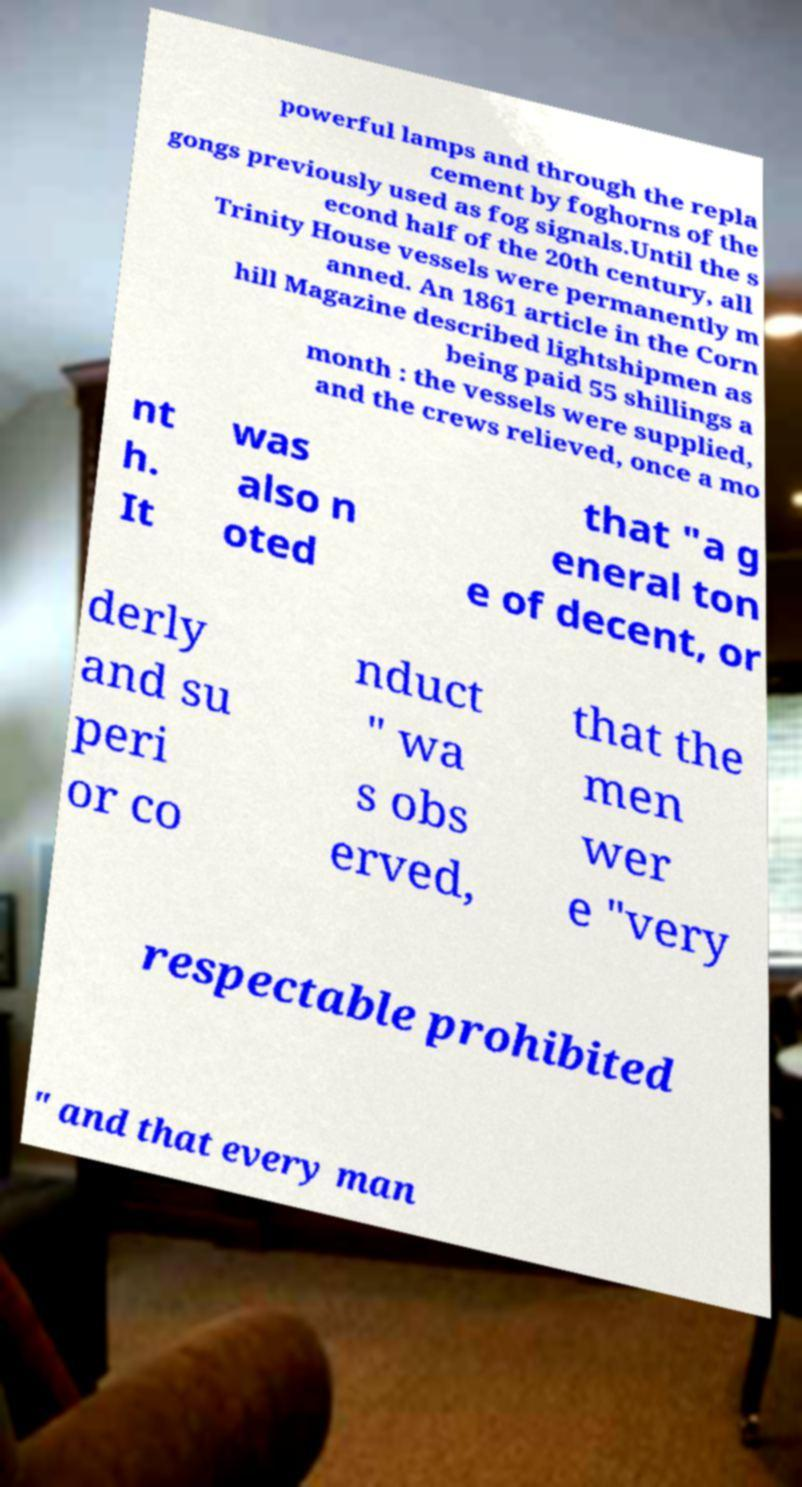I need the written content from this picture converted into text. Can you do that? powerful lamps and through the repla cement by foghorns of the gongs previously used as fog signals.Until the s econd half of the 20th century, all Trinity House vessels were permanently m anned. An 1861 article in the Corn hill Magazine described lightshipmen as being paid 55 shillings a month : the vessels were supplied, and the crews relieved, once a mo nt h. It was also n oted that "a g eneral ton e of decent, or derly and su peri or co nduct " wa s obs erved, that the men wer e "very respectable prohibited " and that every man 